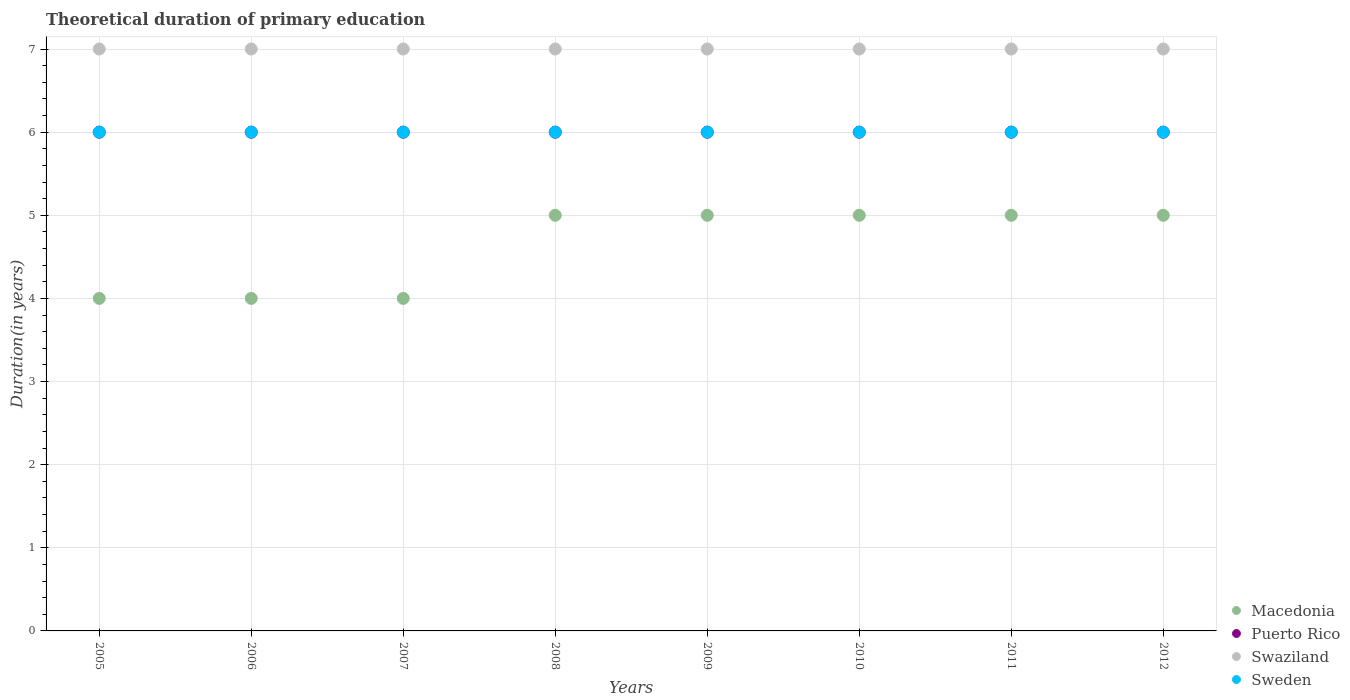How many different coloured dotlines are there?
Ensure brevity in your answer.  4. Is the number of dotlines equal to the number of legend labels?
Offer a very short reply. Yes. Across all years, what is the maximum total theoretical duration of primary education in Sweden?
Your response must be concise. 6. Across all years, what is the minimum total theoretical duration of primary education in Puerto Rico?
Make the answer very short. 6. In which year was the total theoretical duration of primary education in Sweden maximum?
Ensure brevity in your answer.  2005. In which year was the total theoretical duration of primary education in Macedonia minimum?
Provide a short and direct response. 2005. What is the total total theoretical duration of primary education in Swaziland in the graph?
Your response must be concise. 56. What is the difference between the total theoretical duration of primary education in Macedonia in 2007 and the total theoretical duration of primary education in Puerto Rico in 2012?
Ensure brevity in your answer.  -2. In the year 2008, what is the difference between the total theoretical duration of primary education in Macedonia and total theoretical duration of primary education in Sweden?
Make the answer very short. -1. In how many years, is the total theoretical duration of primary education in Puerto Rico greater than 1.2 years?
Provide a succinct answer. 8. What is the ratio of the total theoretical duration of primary education in Macedonia in 2011 to that in 2012?
Your response must be concise. 1. Is the total theoretical duration of primary education in Puerto Rico in 2008 less than that in 2011?
Your response must be concise. No. Is the difference between the total theoretical duration of primary education in Macedonia in 2010 and 2011 greater than the difference between the total theoretical duration of primary education in Sweden in 2010 and 2011?
Offer a terse response. No. What is the difference between the highest and the second highest total theoretical duration of primary education in Swaziland?
Offer a terse response. 0. What is the difference between the highest and the lowest total theoretical duration of primary education in Macedonia?
Keep it short and to the point. 1. Is it the case that in every year, the sum of the total theoretical duration of primary education in Macedonia and total theoretical duration of primary education in Sweden  is greater than the sum of total theoretical duration of primary education in Puerto Rico and total theoretical duration of primary education in Swaziland?
Ensure brevity in your answer.  No. Is it the case that in every year, the sum of the total theoretical duration of primary education in Puerto Rico and total theoretical duration of primary education in Sweden  is greater than the total theoretical duration of primary education in Macedonia?
Give a very brief answer. Yes. Is the total theoretical duration of primary education in Puerto Rico strictly greater than the total theoretical duration of primary education in Sweden over the years?
Offer a very short reply. No. How many years are there in the graph?
Offer a terse response. 8. What is the difference between two consecutive major ticks on the Y-axis?
Offer a very short reply. 1. Does the graph contain grids?
Offer a very short reply. Yes. Where does the legend appear in the graph?
Provide a short and direct response. Bottom right. What is the title of the graph?
Provide a succinct answer. Theoretical duration of primary education. What is the label or title of the X-axis?
Ensure brevity in your answer.  Years. What is the label or title of the Y-axis?
Your answer should be very brief. Duration(in years). What is the Duration(in years) in Puerto Rico in 2005?
Provide a short and direct response. 6. What is the Duration(in years) of Sweden in 2005?
Ensure brevity in your answer.  6. What is the Duration(in years) of Macedonia in 2006?
Keep it short and to the point. 4. What is the Duration(in years) of Swaziland in 2006?
Provide a short and direct response. 7. What is the Duration(in years) in Macedonia in 2007?
Provide a succinct answer. 4. What is the Duration(in years) in Puerto Rico in 2007?
Give a very brief answer. 6. What is the Duration(in years) in Swaziland in 2007?
Your answer should be compact. 7. What is the Duration(in years) of Sweden in 2008?
Offer a very short reply. 6. What is the Duration(in years) in Swaziland in 2009?
Your response must be concise. 7. What is the Duration(in years) in Sweden in 2009?
Your answer should be very brief. 6. What is the Duration(in years) of Puerto Rico in 2010?
Offer a terse response. 6. What is the Duration(in years) of Swaziland in 2010?
Give a very brief answer. 7. What is the Duration(in years) of Swaziland in 2011?
Your response must be concise. 7. What is the Duration(in years) of Macedonia in 2012?
Ensure brevity in your answer.  5. What is the Duration(in years) of Puerto Rico in 2012?
Keep it short and to the point. 6. What is the Duration(in years) in Sweden in 2012?
Provide a succinct answer. 6. Across all years, what is the maximum Duration(in years) in Macedonia?
Give a very brief answer. 5. Across all years, what is the maximum Duration(in years) in Swaziland?
Your response must be concise. 7. Across all years, what is the minimum Duration(in years) in Macedonia?
Your answer should be compact. 4. Across all years, what is the minimum Duration(in years) in Swaziland?
Offer a terse response. 7. What is the total Duration(in years) of Puerto Rico in the graph?
Offer a very short reply. 48. What is the total Duration(in years) of Swaziland in the graph?
Your answer should be very brief. 56. What is the total Duration(in years) in Sweden in the graph?
Give a very brief answer. 48. What is the difference between the Duration(in years) in Puerto Rico in 2005 and that in 2006?
Offer a very short reply. 0. What is the difference between the Duration(in years) in Sweden in 2005 and that in 2006?
Provide a succinct answer. 0. What is the difference between the Duration(in years) of Macedonia in 2005 and that in 2007?
Offer a terse response. 0. What is the difference between the Duration(in years) in Macedonia in 2005 and that in 2008?
Your response must be concise. -1. What is the difference between the Duration(in years) of Sweden in 2005 and that in 2008?
Your response must be concise. 0. What is the difference between the Duration(in years) of Macedonia in 2005 and that in 2009?
Keep it short and to the point. -1. What is the difference between the Duration(in years) in Swaziland in 2005 and that in 2009?
Your answer should be very brief. 0. What is the difference between the Duration(in years) of Sweden in 2005 and that in 2009?
Provide a short and direct response. 0. What is the difference between the Duration(in years) in Puerto Rico in 2005 and that in 2010?
Offer a very short reply. 0. What is the difference between the Duration(in years) of Swaziland in 2005 and that in 2010?
Offer a terse response. 0. What is the difference between the Duration(in years) of Sweden in 2005 and that in 2010?
Provide a short and direct response. 0. What is the difference between the Duration(in years) in Puerto Rico in 2005 and that in 2011?
Keep it short and to the point. 0. What is the difference between the Duration(in years) in Sweden in 2005 and that in 2011?
Offer a terse response. 0. What is the difference between the Duration(in years) in Macedonia in 2005 and that in 2012?
Your response must be concise. -1. What is the difference between the Duration(in years) in Swaziland in 2005 and that in 2012?
Keep it short and to the point. 0. What is the difference between the Duration(in years) of Sweden in 2005 and that in 2012?
Provide a succinct answer. 0. What is the difference between the Duration(in years) of Puerto Rico in 2006 and that in 2007?
Keep it short and to the point. 0. What is the difference between the Duration(in years) in Sweden in 2006 and that in 2007?
Ensure brevity in your answer.  0. What is the difference between the Duration(in years) in Macedonia in 2006 and that in 2008?
Ensure brevity in your answer.  -1. What is the difference between the Duration(in years) of Swaziland in 2006 and that in 2008?
Make the answer very short. 0. What is the difference between the Duration(in years) of Macedonia in 2006 and that in 2011?
Keep it short and to the point. -1. What is the difference between the Duration(in years) in Swaziland in 2006 and that in 2011?
Offer a terse response. 0. What is the difference between the Duration(in years) of Puerto Rico in 2006 and that in 2012?
Make the answer very short. 0. What is the difference between the Duration(in years) of Sweden in 2006 and that in 2012?
Provide a short and direct response. 0. What is the difference between the Duration(in years) of Macedonia in 2007 and that in 2008?
Provide a succinct answer. -1. What is the difference between the Duration(in years) of Sweden in 2007 and that in 2010?
Ensure brevity in your answer.  0. What is the difference between the Duration(in years) of Macedonia in 2007 and that in 2011?
Your response must be concise. -1. What is the difference between the Duration(in years) in Puerto Rico in 2007 and that in 2011?
Provide a short and direct response. 0. What is the difference between the Duration(in years) of Sweden in 2007 and that in 2011?
Make the answer very short. 0. What is the difference between the Duration(in years) in Macedonia in 2007 and that in 2012?
Keep it short and to the point. -1. What is the difference between the Duration(in years) in Swaziland in 2008 and that in 2010?
Give a very brief answer. 0. What is the difference between the Duration(in years) of Sweden in 2008 and that in 2010?
Your answer should be compact. 0. What is the difference between the Duration(in years) in Puerto Rico in 2008 and that in 2011?
Your response must be concise. 0. What is the difference between the Duration(in years) in Swaziland in 2008 and that in 2011?
Your response must be concise. 0. What is the difference between the Duration(in years) of Sweden in 2008 and that in 2011?
Keep it short and to the point. 0. What is the difference between the Duration(in years) of Macedonia in 2008 and that in 2012?
Give a very brief answer. 0. What is the difference between the Duration(in years) of Sweden in 2008 and that in 2012?
Offer a very short reply. 0. What is the difference between the Duration(in years) of Macedonia in 2009 and that in 2010?
Ensure brevity in your answer.  0. What is the difference between the Duration(in years) of Puerto Rico in 2009 and that in 2010?
Ensure brevity in your answer.  0. What is the difference between the Duration(in years) in Sweden in 2009 and that in 2010?
Your answer should be very brief. 0. What is the difference between the Duration(in years) in Swaziland in 2009 and that in 2011?
Your response must be concise. 0. What is the difference between the Duration(in years) in Sweden in 2009 and that in 2011?
Your answer should be compact. 0. What is the difference between the Duration(in years) of Sweden in 2009 and that in 2012?
Provide a short and direct response. 0. What is the difference between the Duration(in years) of Swaziland in 2010 and that in 2011?
Give a very brief answer. 0. What is the difference between the Duration(in years) in Sweden in 2010 and that in 2011?
Your answer should be compact. 0. What is the difference between the Duration(in years) in Macedonia in 2010 and that in 2012?
Ensure brevity in your answer.  0. What is the difference between the Duration(in years) in Macedonia in 2011 and that in 2012?
Your answer should be compact. 0. What is the difference between the Duration(in years) in Puerto Rico in 2011 and that in 2012?
Ensure brevity in your answer.  0. What is the difference between the Duration(in years) in Macedonia in 2005 and the Duration(in years) in Swaziland in 2006?
Your answer should be very brief. -3. What is the difference between the Duration(in years) of Macedonia in 2005 and the Duration(in years) of Sweden in 2006?
Give a very brief answer. -2. What is the difference between the Duration(in years) in Puerto Rico in 2005 and the Duration(in years) in Sweden in 2006?
Give a very brief answer. 0. What is the difference between the Duration(in years) in Puerto Rico in 2005 and the Duration(in years) in Swaziland in 2007?
Give a very brief answer. -1. What is the difference between the Duration(in years) in Swaziland in 2005 and the Duration(in years) in Sweden in 2007?
Your response must be concise. 1. What is the difference between the Duration(in years) of Macedonia in 2005 and the Duration(in years) of Swaziland in 2008?
Keep it short and to the point. -3. What is the difference between the Duration(in years) of Puerto Rico in 2005 and the Duration(in years) of Sweden in 2008?
Your response must be concise. 0. What is the difference between the Duration(in years) in Macedonia in 2005 and the Duration(in years) in Puerto Rico in 2009?
Ensure brevity in your answer.  -2. What is the difference between the Duration(in years) in Macedonia in 2005 and the Duration(in years) in Swaziland in 2009?
Your answer should be very brief. -3. What is the difference between the Duration(in years) of Puerto Rico in 2005 and the Duration(in years) of Sweden in 2009?
Offer a terse response. 0. What is the difference between the Duration(in years) of Macedonia in 2005 and the Duration(in years) of Puerto Rico in 2010?
Provide a succinct answer. -2. What is the difference between the Duration(in years) of Macedonia in 2005 and the Duration(in years) of Swaziland in 2010?
Provide a short and direct response. -3. What is the difference between the Duration(in years) in Puerto Rico in 2005 and the Duration(in years) in Sweden in 2010?
Give a very brief answer. 0. What is the difference between the Duration(in years) of Swaziland in 2005 and the Duration(in years) of Sweden in 2010?
Your answer should be compact. 1. What is the difference between the Duration(in years) of Swaziland in 2005 and the Duration(in years) of Sweden in 2011?
Offer a very short reply. 1. What is the difference between the Duration(in years) in Puerto Rico in 2005 and the Duration(in years) in Swaziland in 2012?
Your answer should be very brief. -1. What is the difference between the Duration(in years) of Swaziland in 2005 and the Duration(in years) of Sweden in 2012?
Give a very brief answer. 1. What is the difference between the Duration(in years) of Macedonia in 2006 and the Duration(in years) of Puerto Rico in 2007?
Provide a short and direct response. -2. What is the difference between the Duration(in years) in Macedonia in 2006 and the Duration(in years) in Swaziland in 2007?
Keep it short and to the point. -3. What is the difference between the Duration(in years) in Puerto Rico in 2006 and the Duration(in years) in Sweden in 2007?
Offer a very short reply. 0. What is the difference between the Duration(in years) in Macedonia in 2006 and the Duration(in years) in Swaziland in 2008?
Your answer should be compact. -3. What is the difference between the Duration(in years) in Puerto Rico in 2006 and the Duration(in years) in Swaziland in 2008?
Keep it short and to the point. -1. What is the difference between the Duration(in years) of Swaziland in 2006 and the Duration(in years) of Sweden in 2008?
Provide a succinct answer. 1. What is the difference between the Duration(in years) in Macedonia in 2006 and the Duration(in years) in Swaziland in 2009?
Ensure brevity in your answer.  -3. What is the difference between the Duration(in years) of Swaziland in 2006 and the Duration(in years) of Sweden in 2009?
Your answer should be very brief. 1. What is the difference between the Duration(in years) in Macedonia in 2006 and the Duration(in years) in Sweden in 2011?
Your response must be concise. -2. What is the difference between the Duration(in years) in Swaziland in 2006 and the Duration(in years) in Sweden in 2011?
Offer a terse response. 1. What is the difference between the Duration(in years) in Puerto Rico in 2006 and the Duration(in years) in Swaziland in 2012?
Your response must be concise. -1. What is the difference between the Duration(in years) in Puerto Rico in 2006 and the Duration(in years) in Sweden in 2012?
Offer a terse response. 0. What is the difference between the Duration(in years) in Macedonia in 2007 and the Duration(in years) in Sweden in 2008?
Offer a terse response. -2. What is the difference between the Duration(in years) of Puerto Rico in 2007 and the Duration(in years) of Swaziland in 2008?
Your response must be concise. -1. What is the difference between the Duration(in years) of Swaziland in 2007 and the Duration(in years) of Sweden in 2008?
Your answer should be compact. 1. What is the difference between the Duration(in years) of Macedonia in 2007 and the Duration(in years) of Swaziland in 2009?
Ensure brevity in your answer.  -3. What is the difference between the Duration(in years) in Macedonia in 2007 and the Duration(in years) in Sweden in 2009?
Offer a very short reply. -2. What is the difference between the Duration(in years) in Macedonia in 2007 and the Duration(in years) in Puerto Rico in 2010?
Offer a terse response. -2. What is the difference between the Duration(in years) in Swaziland in 2007 and the Duration(in years) in Sweden in 2010?
Your answer should be very brief. 1. What is the difference between the Duration(in years) in Macedonia in 2007 and the Duration(in years) in Swaziland in 2011?
Provide a short and direct response. -3. What is the difference between the Duration(in years) of Macedonia in 2007 and the Duration(in years) of Sweden in 2011?
Offer a very short reply. -2. What is the difference between the Duration(in years) in Puerto Rico in 2007 and the Duration(in years) in Swaziland in 2011?
Offer a terse response. -1. What is the difference between the Duration(in years) of Swaziland in 2007 and the Duration(in years) of Sweden in 2011?
Your response must be concise. 1. What is the difference between the Duration(in years) in Macedonia in 2007 and the Duration(in years) in Sweden in 2012?
Make the answer very short. -2. What is the difference between the Duration(in years) of Puerto Rico in 2007 and the Duration(in years) of Swaziland in 2012?
Offer a terse response. -1. What is the difference between the Duration(in years) in Swaziland in 2007 and the Duration(in years) in Sweden in 2012?
Provide a short and direct response. 1. What is the difference between the Duration(in years) of Macedonia in 2008 and the Duration(in years) of Sweden in 2009?
Your answer should be very brief. -1. What is the difference between the Duration(in years) of Puerto Rico in 2008 and the Duration(in years) of Sweden in 2009?
Your response must be concise. 0. What is the difference between the Duration(in years) in Macedonia in 2008 and the Duration(in years) in Puerto Rico in 2010?
Provide a short and direct response. -1. What is the difference between the Duration(in years) in Puerto Rico in 2008 and the Duration(in years) in Sweden in 2010?
Keep it short and to the point. 0. What is the difference between the Duration(in years) of Macedonia in 2008 and the Duration(in years) of Puerto Rico in 2011?
Your response must be concise. -1. What is the difference between the Duration(in years) in Macedonia in 2008 and the Duration(in years) in Swaziland in 2011?
Ensure brevity in your answer.  -2. What is the difference between the Duration(in years) of Puerto Rico in 2008 and the Duration(in years) of Swaziland in 2011?
Offer a terse response. -1. What is the difference between the Duration(in years) of Swaziland in 2008 and the Duration(in years) of Sweden in 2011?
Make the answer very short. 1. What is the difference between the Duration(in years) in Macedonia in 2008 and the Duration(in years) in Puerto Rico in 2012?
Provide a succinct answer. -1. What is the difference between the Duration(in years) of Macedonia in 2008 and the Duration(in years) of Swaziland in 2012?
Offer a terse response. -2. What is the difference between the Duration(in years) of Macedonia in 2008 and the Duration(in years) of Sweden in 2012?
Keep it short and to the point. -1. What is the difference between the Duration(in years) of Puerto Rico in 2008 and the Duration(in years) of Swaziland in 2012?
Make the answer very short. -1. What is the difference between the Duration(in years) of Puerto Rico in 2008 and the Duration(in years) of Sweden in 2012?
Your response must be concise. 0. What is the difference between the Duration(in years) in Swaziland in 2008 and the Duration(in years) in Sweden in 2012?
Your response must be concise. 1. What is the difference between the Duration(in years) of Macedonia in 2009 and the Duration(in years) of Puerto Rico in 2010?
Make the answer very short. -1. What is the difference between the Duration(in years) in Macedonia in 2009 and the Duration(in years) in Sweden in 2010?
Provide a succinct answer. -1. What is the difference between the Duration(in years) in Macedonia in 2009 and the Duration(in years) in Puerto Rico in 2011?
Keep it short and to the point. -1. What is the difference between the Duration(in years) in Macedonia in 2009 and the Duration(in years) in Swaziland in 2011?
Offer a terse response. -2. What is the difference between the Duration(in years) in Macedonia in 2009 and the Duration(in years) in Sweden in 2011?
Offer a terse response. -1. What is the difference between the Duration(in years) of Puerto Rico in 2009 and the Duration(in years) of Swaziland in 2011?
Provide a short and direct response. -1. What is the difference between the Duration(in years) in Macedonia in 2009 and the Duration(in years) in Puerto Rico in 2012?
Your response must be concise. -1. What is the difference between the Duration(in years) in Macedonia in 2009 and the Duration(in years) in Swaziland in 2012?
Make the answer very short. -2. What is the difference between the Duration(in years) of Macedonia in 2010 and the Duration(in years) of Puerto Rico in 2011?
Your answer should be compact. -1. What is the difference between the Duration(in years) of Macedonia in 2010 and the Duration(in years) of Sweden in 2011?
Your response must be concise. -1. What is the difference between the Duration(in years) of Puerto Rico in 2010 and the Duration(in years) of Sweden in 2011?
Make the answer very short. 0. What is the difference between the Duration(in years) in Macedonia in 2010 and the Duration(in years) in Puerto Rico in 2012?
Keep it short and to the point. -1. What is the difference between the Duration(in years) in Puerto Rico in 2010 and the Duration(in years) in Swaziland in 2012?
Offer a very short reply. -1. What is the difference between the Duration(in years) of Macedonia in 2011 and the Duration(in years) of Puerto Rico in 2012?
Your response must be concise. -1. What is the difference between the Duration(in years) in Macedonia in 2011 and the Duration(in years) in Sweden in 2012?
Provide a short and direct response. -1. What is the difference between the Duration(in years) in Puerto Rico in 2011 and the Duration(in years) in Swaziland in 2012?
Your answer should be very brief. -1. What is the difference between the Duration(in years) of Swaziland in 2011 and the Duration(in years) of Sweden in 2012?
Give a very brief answer. 1. What is the average Duration(in years) of Macedonia per year?
Ensure brevity in your answer.  4.62. What is the average Duration(in years) in Puerto Rico per year?
Give a very brief answer. 6. What is the average Duration(in years) of Sweden per year?
Keep it short and to the point. 6. In the year 2005, what is the difference between the Duration(in years) of Macedonia and Duration(in years) of Puerto Rico?
Make the answer very short. -2. In the year 2005, what is the difference between the Duration(in years) in Puerto Rico and Duration(in years) in Swaziland?
Your answer should be compact. -1. In the year 2005, what is the difference between the Duration(in years) in Puerto Rico and Duration(in years) in Sweden?
Offer a very short reply. 0. In the year 2006, what is the difference between the Duration(in years) in Macedonia and Duration(in years) in Puerto Rico?
Your answer should be very brief. -2. In the year 2006, what is the difference between the Duration(in years) in Macedonia and Duration(in years) in Swaziland?
Provide a short and direct response. -3. In the year 2006, what is the difference between the Duration(in years) in Puerto Rico and Duration(in years) in Swaziland?
Give a very brief answer. -1. In the year 2007, what is the difference between the Duration(in years) of Puerto Rico and Duration(in years) of Swaziland?
Make the answer very short. -1. In the year 2007, what is the difference between the Duration(in years) in Puerto Rico and Duration(in years) in Sweden?
Offer a terse response. 0. In the year 2008, what is the difference between the Duration(in years) of Macedonia and Duration(in years) of Puerto Rico?
Give a very brief answer. -1. In the year 2008, what is the difference between the Duration(in years) in Macedonia and Duration(in years) in Sweden?
Provide a succinct answer. -1. In the year 2009, what is the difference between the Duration(in years) of Macedonia and Duration(in years) of Puerto Rico?
Your answer should be compact. -1. In the year 2009, what is the difference between the Duration(in years) in Macedonia and Duration(in years) in Swaziland?
Keep it short and to the point. -2. In the year 2009, what is the difference between the Duration(in years) in Macedonia and Duration(in years) in Sweden?
Your response must be concise. -1. In the year 2009, what is the difference between the Duration(in years) of Swaziland and Duration(in years) of Sweden?
Provide a short and direct response. 1. In the year 2010, what is the difference between the Duration(in years) in Puerto Rico and Duration(in years) in Swaziland?
Give a very brief answer. -1. In the year 2011, what is the difference between the Duration(in years) of Macedonia and Duration(in years) of Puerto Rico?
Offer a very short reply. -1. In the year 2011, what is the difference between the Duration(in years) in Macedonia and Duration(in years) in Swaziland?
Keep it short and to the point. -2. In the year 2012, what is the difference between the Duration(in years) of Macedonia and Duration(in years) of Puerto Rico?
Give a very brief answer. -1. In the year 2012, what is the difference between the Duration(in years) in Macedonia and Duration(in years) in Sweden?
Provide a short and direct response. -1. In the year 2012, what is the difference between the Duration(in years) in Swaziland and Duration(in years) in Sweden?
Offer a very short reply. 1. What is the ratio of the Duration(in years) of Macedonia in 2005 to that in 2006?
Provide a succinct answer. 1. What is the ratio of the Duration(in years) in Puerto Rico in 2005 to that in 2006?
Offer a very short reply. 1. What is the ratio of the Duration(in years) in Swaziland in 2005 to that in 2007?
Offer a terse response. 1. What is the ratio of the Duration(in years) of Sweden in 2005 to that in 2007?
Your response must be concise. 1. What is the ratio of the Duration(in years) in Macedonia in 2005 to that in 2008?
Your answer should be compact. 0.8. What is the ratio of the Duration(in years) of Puerto Rico in 2005 to that in 2008?
Keep it short and to the point. 1. What is the ratio of the Duration(in years) in Swaziland in 2005 to that in 2008?
Provide a short and direct response. 1. What is the ratio of the Duration(in years) of Sweden in 2005 to that in 2008?
Keep it short and to the point. 1. What is the ratio of the Duration(in years) in Macedonia in 2005 to that in 2009?
Provide a short and direct response. 0.8. What is the ratio of the Duration(in years) of Macedonia in 2005 to that in 2010?
Offer a terse response. 0.8. What is the ratio of the Duration(in years) in Puerto Rico in 2005 to that in 2010?
Offer a terse response. 1. What is the ratio of the Duration(in years) in Swaziland in 2005 to that in 2010?
Offer a terse response. 1. What is the ratio of the Duration(in years) of Sweden in 2005 to that in 2010?
Your answer should be very brief. 1. What is the ratio of the Duration(in years) of Macedonia in 2005 to that in 2011?
Make the answer very short. 0.8. What is the ratio of the Duration(in years) in Swaziland in 2005 to that in 2011?
Provide a short and direct response. 1. What is the ratio of the Duration(in years) in Swaziland in 2005 to that in 2012?
Give a very brief answer. 1. What is the ratio of the Duration(in years) in Sweden in 2005 to that in 2012?
Provide a short and direct response. 1. What is the ratio of the Duration(in years) in Puerto Rico in 2006 to that in 2007?
Offer a terse response. 1. What is the ratio of the Duration(in years) in Swaziland in 2006 to that in 2008?
Make the answer very short. 1. What is the ratio of the Duration(in years) in Sweden in 2006 to that in 2008?
Your answer should be compact. 1. What is the ratio of the Duration(in years) in Puerto Rico in 2006 to that in 2009?
Your answer should be compact. 1. What is the ratio of the Duration(in years) of Swaziland in 2006 to that in 2009?
Offer a very short reply. 1. What is the ratio of the Duration(in years) of Macedonia in 2006 to that in 2010?
Provide a succinct answer. 0.8. What is the ratio of the Duration(in years) of Puerto Rico in 2006 to that in 2010?
Provide a short and direct response. 1. What is the ratio of the Duration(in years) in Swaziland in 2006 to that in 2010?
Ensure brevity in your answer.  1. What is the ratio of the Duration(in years) of Puerto Rico in 2006 to that in 2011?
Your answer should be compact. 1. What is the ratio of the Duration(in years) of Sweden in 2006 to that in 2011?
Provide a short and direct response. 1. What is the ratio of the Duration(in years) in Macedonia in 2006 to that in 2012?
Ensure brevity in your answer.  0.8. What is the ratio of the Duration(in years) of Puerto Rico in 2006 to that in 2012?
Your answer should be compact. 1. What is the ratio of the Duration(in years) of Sweden in 2007 to that in 2008?
Your answer should be very brief. 1. What is the ratio of the Duration(in years) of Macedonia in 2007 to that in 2009?
Make the answer very short. 0.8. What is the ratio of the Duration(in years) in Puerto Rico in 2007 to that in 2009?
Ensure brevity in your answer.  1. What is the ratio of the Duration(in years) in Swaziland in 2007 to that in 2009?
Keep it short and to the point. 1. What is the ratio of the Duration(in years) of Macedonia in 2007 to that in 2010?
Provide a short and direct response. 0.8. What is the ratio of the Duration(in years) of Puerto Rico in 2007 to that in 2010?
Give a very brief answer. 1. What is the ratio of the Duration(in years) in Swaziland in 2007 to that in 2010?
Your answer should be very brief. 1. What is the ratio of the Duration(in years) of Macedonia in 2007 to that in 2011?
Your answer should be compact. 0.8. What is the ratio of the Duration(in years) of Puerto Rico in 2007 to that in 2011?
Your response must be concise. 1. What is the ratio of the Duration(in years) in Swaziland in 2007 to that in 2011?
Ensure brevity in your answer.  1. What is the ratio of the Duration(in years) of Swaziland in 2008 to that in 2009?
Provide a short and direct response. 1. What is the ratio of the Duration(in years) of Sweden in 2008 to that in 2009?
Make the answer very short. 1. What is the ratio of the Duration(in years) of Puerto Rico in 2008 to that in 2010?
Your response must be concise. 1. What is the ratio of the Duration(in years) of Sweden in 2008 to that in 2010?
Offer a very short reply. 1. What is the ratio of the Duration(in years) in Macedonia in 2008 to that in 2011?
Provide a succinct answer. 1. What is the ratio of the Duration(in years) in Puerto Rico in 2008 to that in 2011?
Provide a short and direct response. 1. What is the ratio of the Duration(in years) of Macedonia in 2008 to that in 2012?
Your response must be concise. 1. What is the ratio of the Duration(in years) in Puerto Rico in 2009 to that in 2010?
Your response must be concise. 1. What is the ratio of the Duration(in years) in Swaziland in 2009 to that in 2010?
Offer a terse response. 1. What is the ratio of the Duration(in years) of Macedonia in 2009 to that in 2011?
Offer a terse response. 1. What is the ratio of the Duration(in years) in Puerto Rico in 2009 to that in 2011?
Keep it short and to the point. 1. What is the ratio of the Duration(in years) of Puerto Rico in 2009 to that in 2012?
Keep it short and to the point. 1. What is the ratio of the Duration(in years) of Swaziland in 2009 to that in 2012?
Your answer should be compact. 1. What is the ratio of the Duration(in years) in Macedonia in 2010 to that in 2011?
Offer a terse response. 1. What is the ratio of the Duration(in years) of Swaziland in 2010 to that in 2011?
Offer a terse response. 1. What is the ratio of the Duration(in years) of Macedonia in 2010 to that in 2012?
Provide a succinct answer. 1. What is the ratio of the Duration(in years) of Swaziland in 2010 to that in 2012?
Provide a short and direct response. 1. What is the ratio of the Duration(in years) in Sweden in 2010 to that in 2012?
Your response must be concise. 1. What is the ratio of the Duration(in years) of Puerto Rico in 2011 to that in 2012?
Offer a terse response. 1. What is the ratio of the Duration(in years) of Swaziland in 2011 to that in 2012?
Offer a terse response. 1. What is the difference between the highest and the second highest Duration(in years) in Macedonia?
Offer a very short reply. 0. What is the difference between the highest and the second highest Duration(in years) in Puerto Rico?
Make the answer very short. 0. What is the difference between the highest and the second highest Duration(in years) in Swaziland?
Your answer should be compact. 0. What is the difference between the highest and the second highest Duration(in years) in Sweden?
Your response must be concise. 0. What is the difference between the highest and the lowest Duration(in years) of Puerto Rico?
Ensure brevity in your answer.  0. 